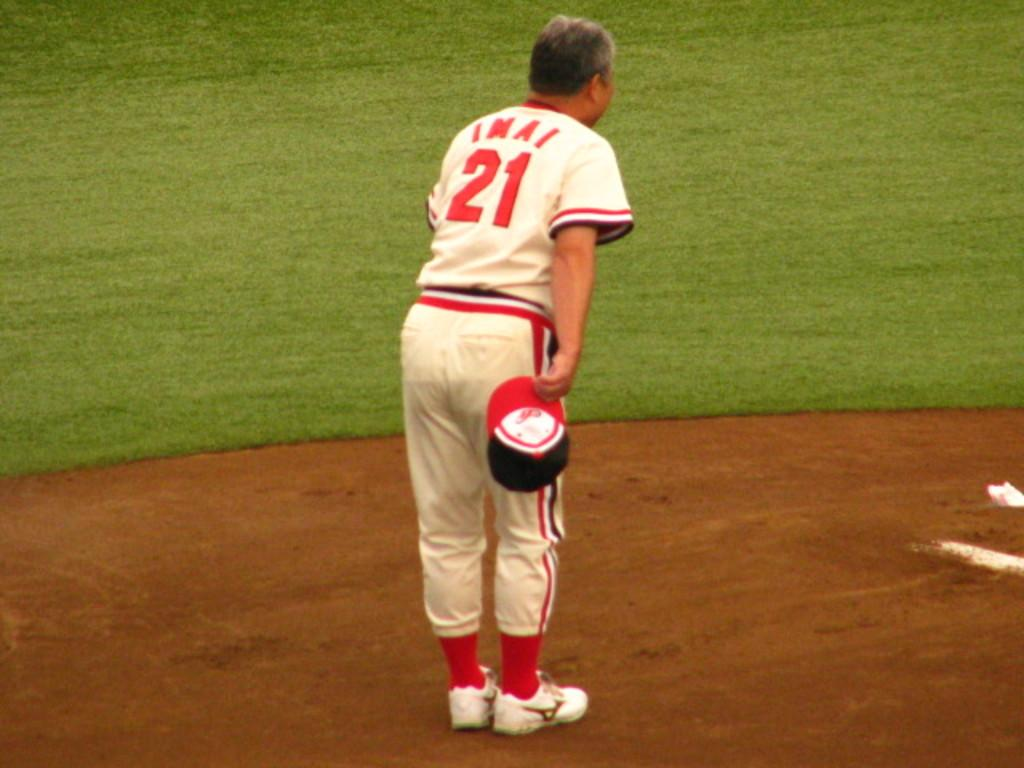<image>
Provide a brief description of the given image. Baseball player wearing jersey number 21 standing on the field. 